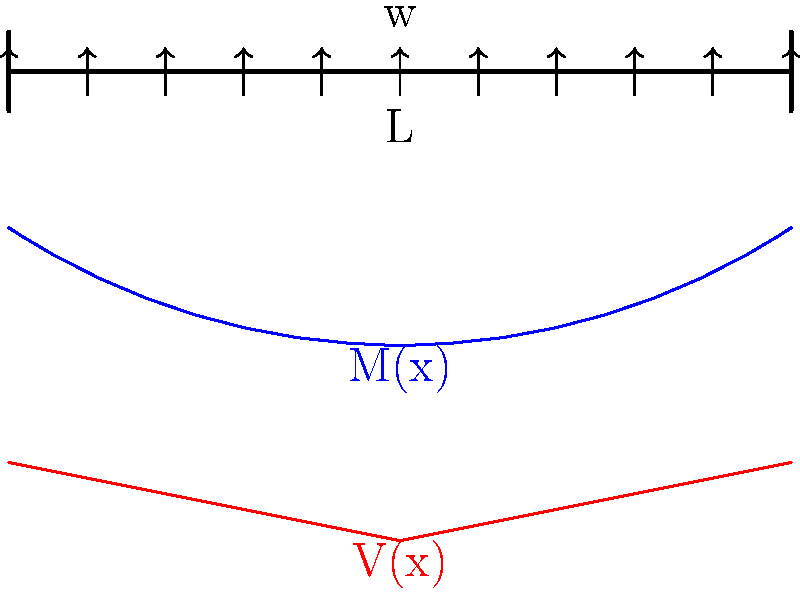As a DIY enthusiast planning a loft conversion, you're considering a simply supported beam of length L to support the new floor. The beam will be subjected to a uniformly distributed load w. Using the beam diagrams provided, determine the maximum bending moment and its location for this configuration. How might this information influence your choice of beam material and dimensions for your renovation project? To solve this problem and understand its implications for a DIY loft conversion, let's follow these steps:

1. Analyze the beam configuration:
   - The beam is simply supported at both ends
   - It's subjected to a uniformly distributed load w
   - The length of the beam is L

2. Determine the maximum bending moment:
   - For a simply supported beam with uniformly distributed load, the maximum bending moment occurs at the center of the beam
   - The formula for maximum bending moment is:
     $$ M_{max} = \frac{wL^2}{8} $$
   - This occurs at x = L/2 (the midpoint of the beam)

3. Interpret the bending moment diagram:
   - The blue curve represents the bending moment distribution
   - It's parabolic, with the maximum at the center
   - This confirms our calculation that the maximum moment is at L/2

4. Consider the shear force diagram:
   - The red line represents the shear force distribution
   - It's linear, with zero shear force at the center
   - This further confirms that the maximum bending moment is at the center

5. Implications for the loft conversion project:
   - The maximum bending moment determines the required strength of the beam
   - You need to choose a beam material and cross-section that can safely resist this moment
   - Consider factors like:
     a. Material strength (e.g., steel vs. wood)
     b. Beam depth (deeper beams generally have higher bending resistance)
     c. Safety factor (always design for loads higher than expected)

6. Additional considerations:
   - Check local building codes for minimum requirements
   - Consider deflection limits for comfort and to prevent damage to finishes
   - Consult with a structural engineer to ensure safety and compliance

By understanding the maximum bending moment and its location, you can make informed decisions about the beam selection, ensuring your DIY loft conversion is both safe and structurally sound.
Answer: $M_{max} = \frac{wL^2}{8}$ at x = L/2; influences material and dimensions choice for safety and structural integrity. 